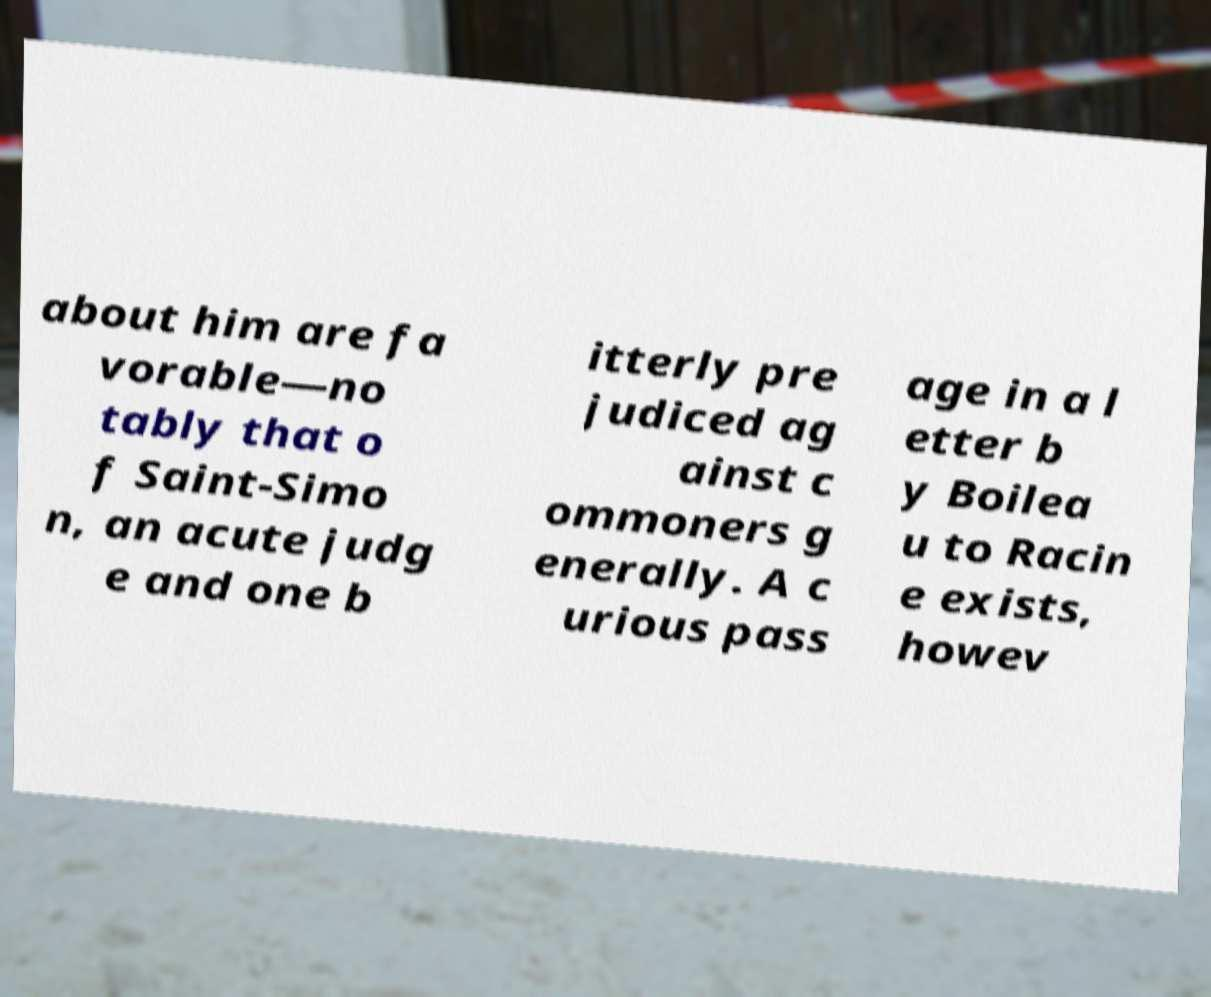Can you accurately transcribe the text from the provided image for me? about him are fa vorable—no tably that o f Saint-Simo n, an acute judg e and one b itterly pre judiced ag ainst c ommoners g enerally. A c urious pass age in a l etter b y Boilea u to Racin e exists, howev 